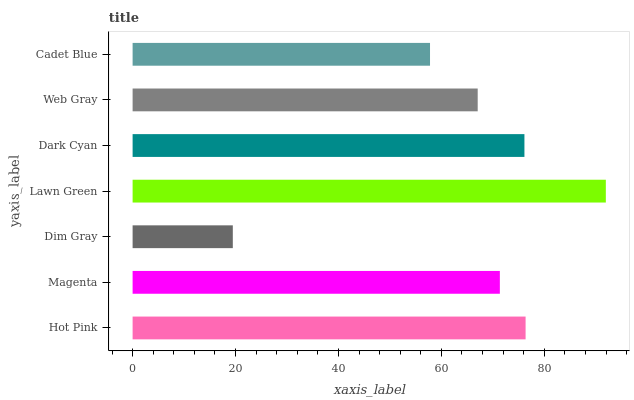Is Dim Gray the minimum?
Answer yes or no. Yes. Is Lawn Green the maximum?
Answer yes or no. Yes. Is Magenta the minimum?
Answer yes or no. No. Is Magenta the maximum?
Answer yes or no. No. Is Hot Pink greater than Magenta?
Answer yes or no. Yes. Is Magenta less than Hot Pink?
Answer yes or no. Yes. Is Magenta greater than Hot Pink?
Answer yes or no. No. Is Hot Pink less than Magenta?
Answer yes or no. No. Is Magenta the high median?
Answer yes or no. Yes. Is Magenta the low median?
Answer yes or no. Yes. Is Hot Pink the high median?
Answer yes or no. No. Is Lawn Green the low median?
Answer yes or no. No. 